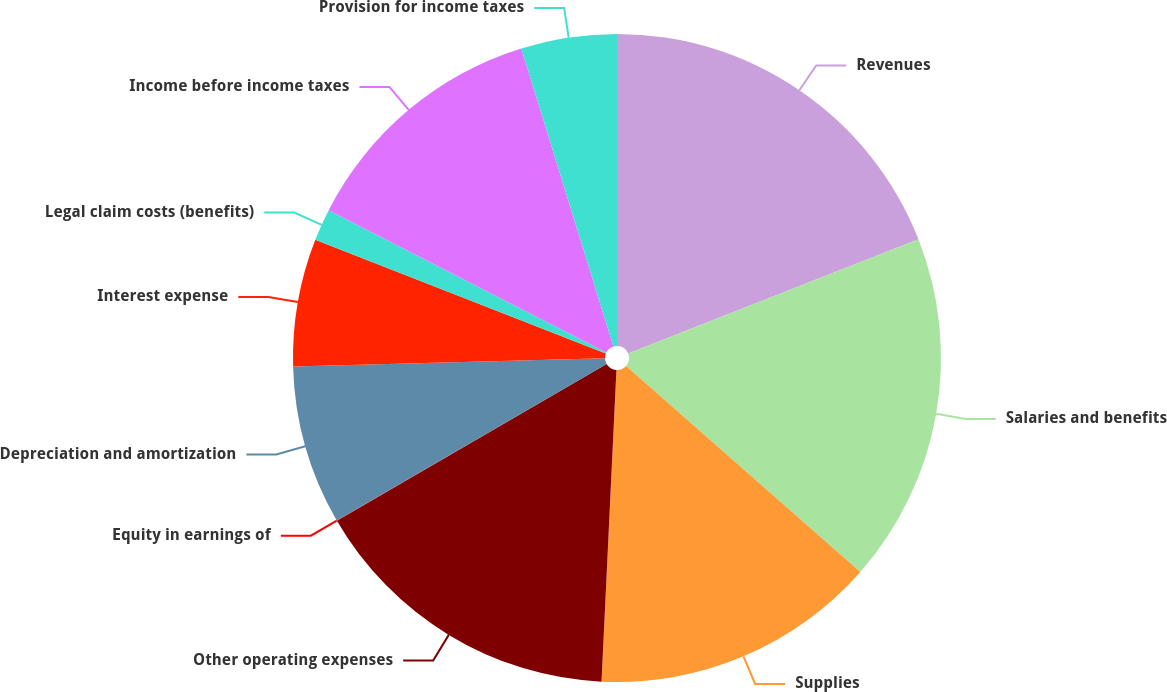Convert chart to OTSL. <chart><loc_0><loc_0><loc_500><loc_500><pie_chart><fcel>Revenues<fcel>Salaries and benefits<fcel>Supplies<fcel>Other operating expenses<fcel>Equity in earnings of<fcel>Depreciation and amortization<fcel>Interest expense<fcel>Legal claim costs (benefits)<fcel>Income before income taxes<fcel>Provision for income taxes<nl><fcel>19.03%<fcel>17.45%<fcel>14.28%<fcel>15.86%<fcel>0.02%<fcel>7.94%<fcel>6.36%<fcel>1.6%<fcel>12.69%<fcel>4.77%<nl></chart> 